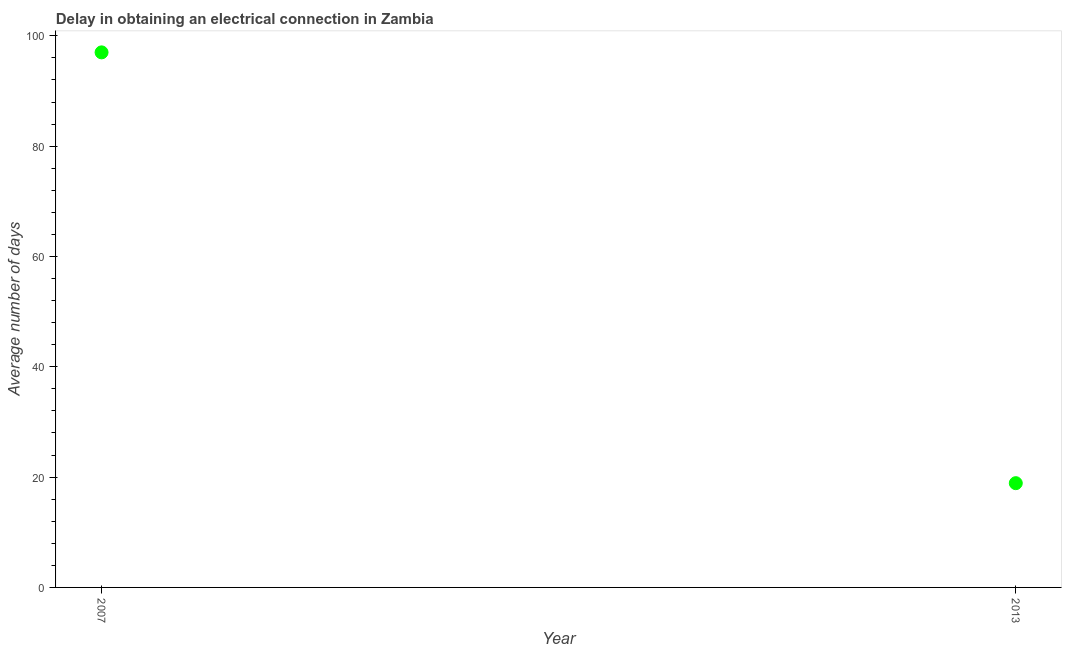What is the dalay in electrical connection in 2007?
Your answer should be very brief. 97. Across all years, what is the maximum dalay in electrical connection?
Provide a succinct answer. 97. What is the sum of the dalay in electrical connection?
Your answer should be compact. 115.9. What is the difference between the dalay in electrical connection in 2007 and 2013?
Offer a terse response. 78.1. What is the average dalay in electrical connection per year?
Give a very brief answer. 57.95. What is the median dalay in electrical connection?
Offer a very short reply. 57.95. In how many years, is the dalay in electrical connection greater than 64 days?
Ensure brevity in your answer.  1. What is the ratio of the dalay in electrical connection in 2007 to that in 2013?
Provide a succinct answer. 5.13. Does the dalay in electrical connection monotonically increase over the years?
Provide a succinct answer. No. How many dotlines are there?
Provide a succinct answer. 1. Are the values on the major ticks of Y-axis written in scientific E-notation?
Offer a terse response. No. Does the graph contain any zero values?
Provide a short and direct response. No. What is the title of the graph?
Give a very brief answer. Delay in obtaining an electrical connection in Zambia. What is the label or title of the X-axis?
Your response must be concise. Year. What is the label or title of the Y-axis?
Your answer should be very brief. Average number of days. What is the Average number of days in 2007?
Keep it short and to the point. 97. What is the Average number of days in 2013?
Give a very brief answer. 18.9. What is the difference between the Average number of days in 2007 and 2013?
Provide a succinct answer. 78.1. What is the ratio of the Average number of days in 2007 to that in 2013?
Ensure brevity in your answer.  5.13. 